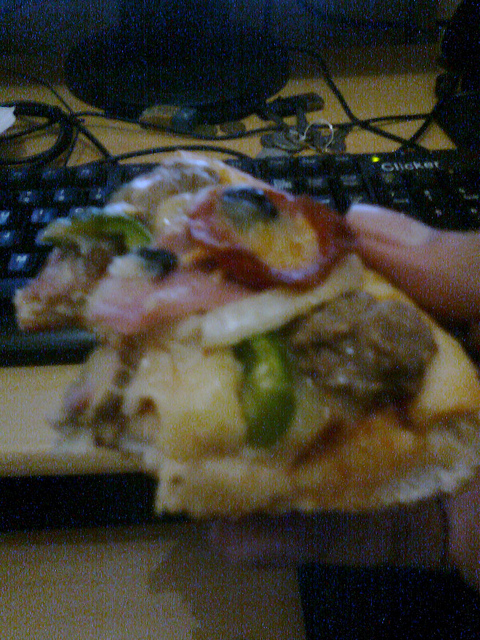Has the pizza been eaten? Yes, the pizza has clearly been bitten into, as seen from the slice being held. 